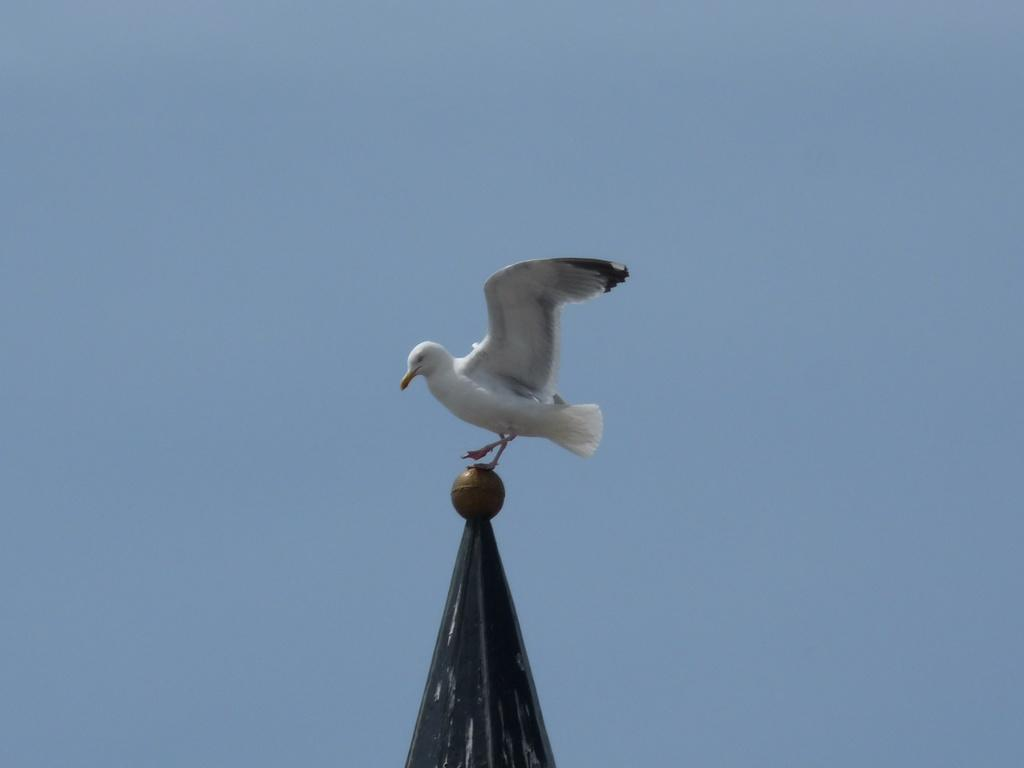What is the main object in the center of the image? There is a pole in the center of the image. What is on top of the pole? There is a round object on the pole. What animal can be seen on the pole? There is a bird on the pole. What colors does the bird have? The bird is white and black in color. What can be seen in the background of the image? The sky is visible in the background of the image. Where is the lunchroom located in the image? There is no lunchroom present in the image. Is the bird teaching a class in the image? There is no indication of teaching or a class in the image; it simply shows a bird on a pole. 